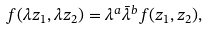Convert formula to latex. <formula><loc_0><loc_0><loc_500><loc_500>f ( \lambda z _ { 1 } , \lambda z _ { 2 } ) = \lambda ^ { a } \bar { \lambda } ^ { b } f ( z _ { 1 } , z _ { 2 } ) ,</formula> 